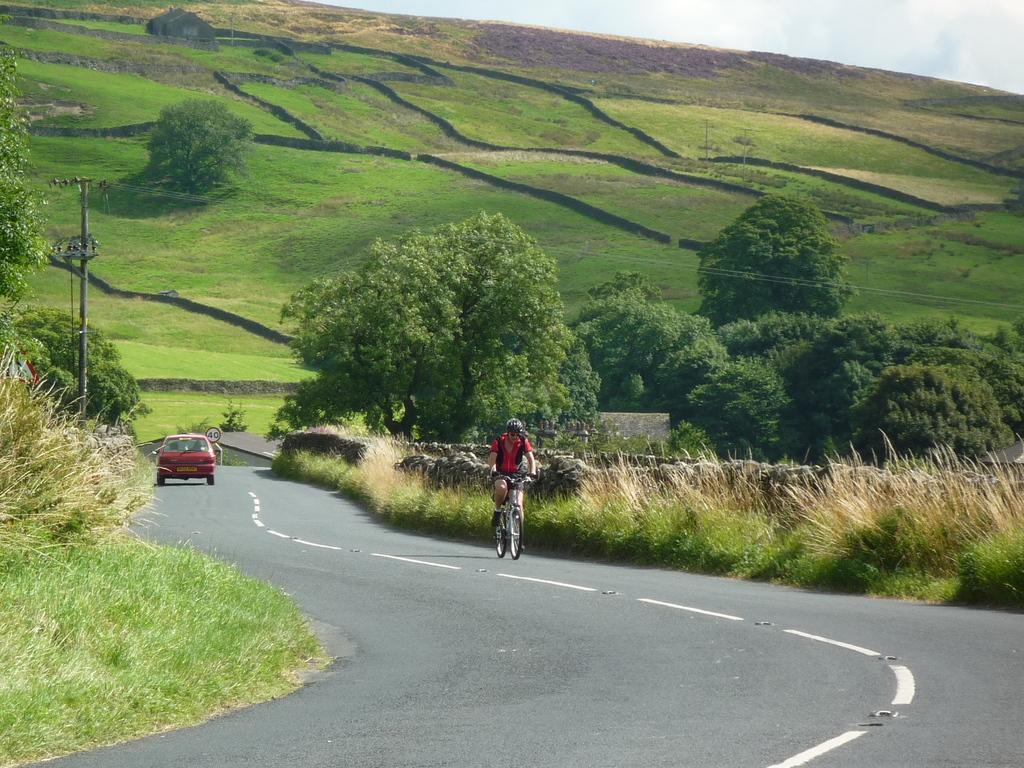Can you describe this image briefly? In this picture I can see there is a person riding the bicycle and there is a car moving on the road and on both sides I can find there is grass, plants and trees and there is a mountain in the backdrop and the sky is clear. 